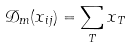Convert formula to latex. <formula><loc_0><loc_0><loc_500><loc_500>\mathcal { D } _ { m } ( x _ { i j } ) = \sum _ { T } x _ { T }</formula> 